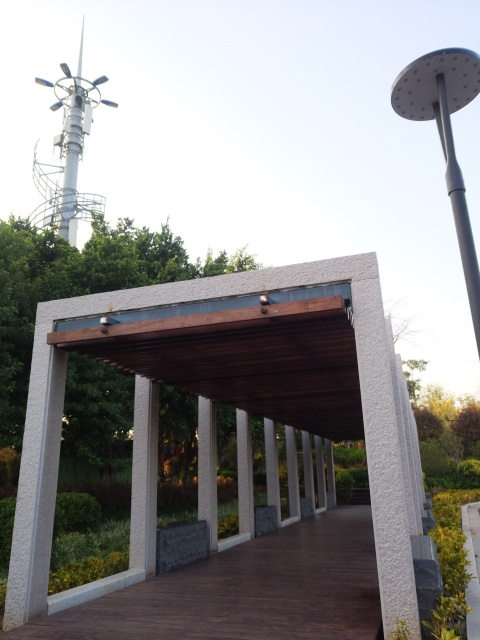Can you describe the architecture of the structure shown in the image? Certainly! The structure in the image is a modern arcaded walkway featuring a series of vertical columns supporting a flat roof. The design is minimalistic with clean lines, and the materials look contemporary, consisting of what appears to be granite or concrete for the columns and a wooden finish for the ceiling. The walkway offers a sheltered path, often found in parks or public spaces, and seems to blend functionality with an aesthetic element. 